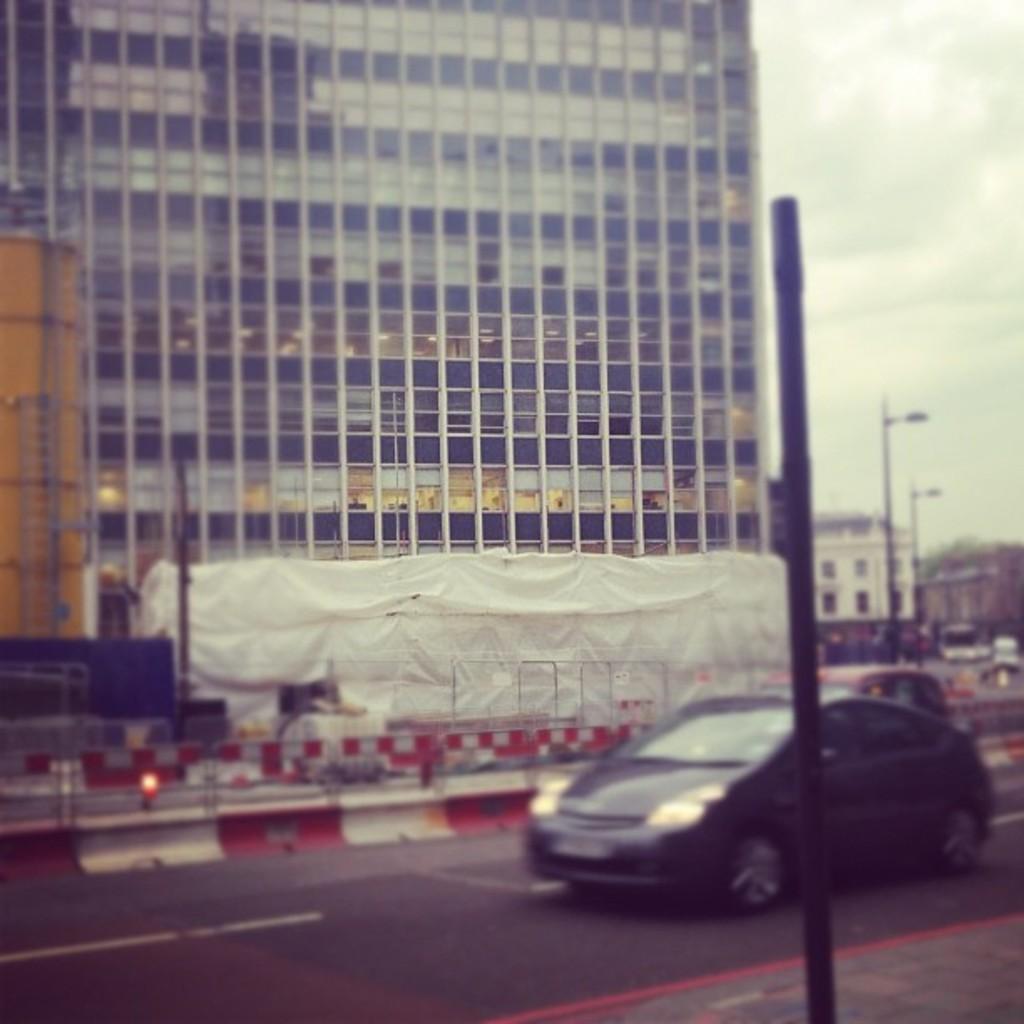In one or two sentences, can you explain what this image depicts? It is a blur image. In this image, we can see few vehicles are on the road. Here we can see poles, buildings, glasses. Background there is a sky. 